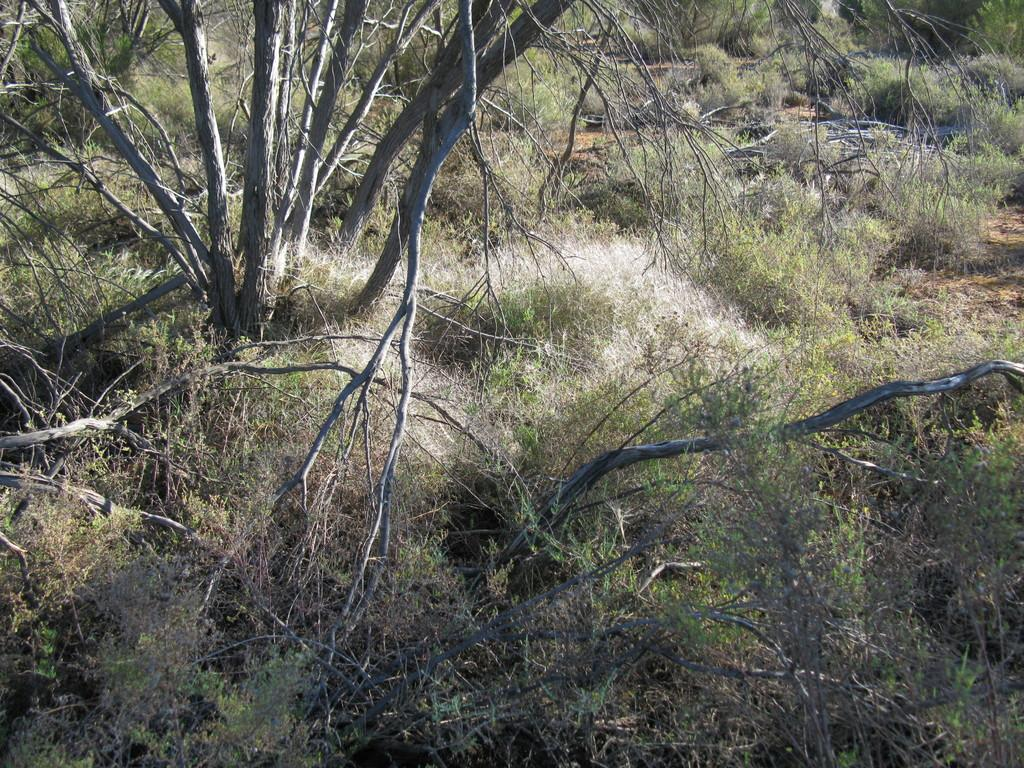What type of vegetation is on the left side of the image? There is a tree on the left side of the image. What type of ground cover is visible at the bottom of the image? Grass is visible at the bottom of the image. What color is the shirt worn by the hand in the image? There is no hand or shirt present in the image. 